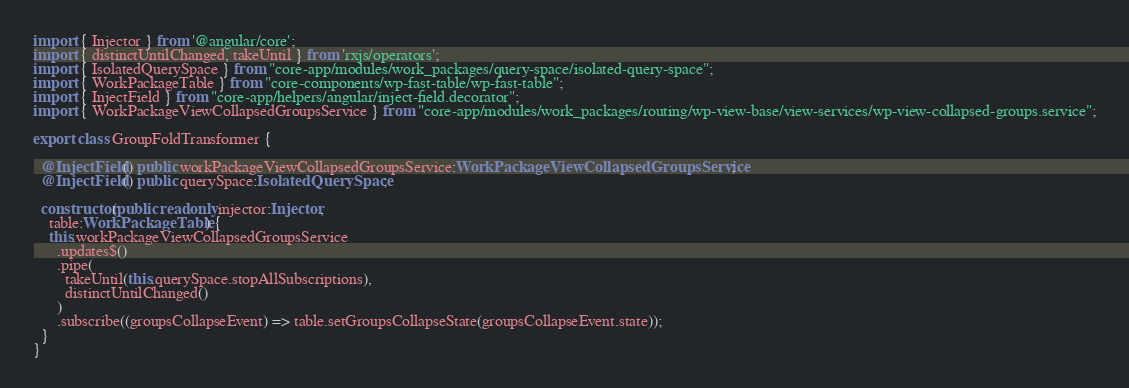Convert code to text. <code><loc_0><loc_0><loc_500><loc_500><_TypeScript_>import { Injector } from '@angular/core';
import { distinctUntilChanged, takeUntil } from 'rxjs/operators';
import { IsolatedQuerySpace } from "core-app/modules/work_packages/query-space/isolated-query-space";
import { WorkPackageTable } from "core-components/wp-fast-table/wp-fast-table";
import { InjectField } from "core-app/helpers/angular/inject-field.decorator";
import { WorkPackageViewCollapsedGroupsService } from "core-app/modules/work_packages/routing/wp-view-base/view-services/wp-view-collapsed-groups.service";

export class GroupFoldTransformer {

  @InjectField() public workPackageViewCollapsedGroupsService:WorkPackageViewCollapsedGroupsService;
  @InjectField() public querySpace:IsolatedQuerySpace;

  constructor(public readonly injector:Injector,
    table:WorkPackageTable) {
    this.workPackageViewCollapsedGroupsService
      .updates$()
      .pipe(
        takeUntil(this.querySpace.stopAllSubscriptions),
        distinctUntilChanged()
      )
      .subscribe((groupsCollapseEvent) => table.setGroupsCollapseState(groupsCollapseEvent.state));
  }
}
</code> 